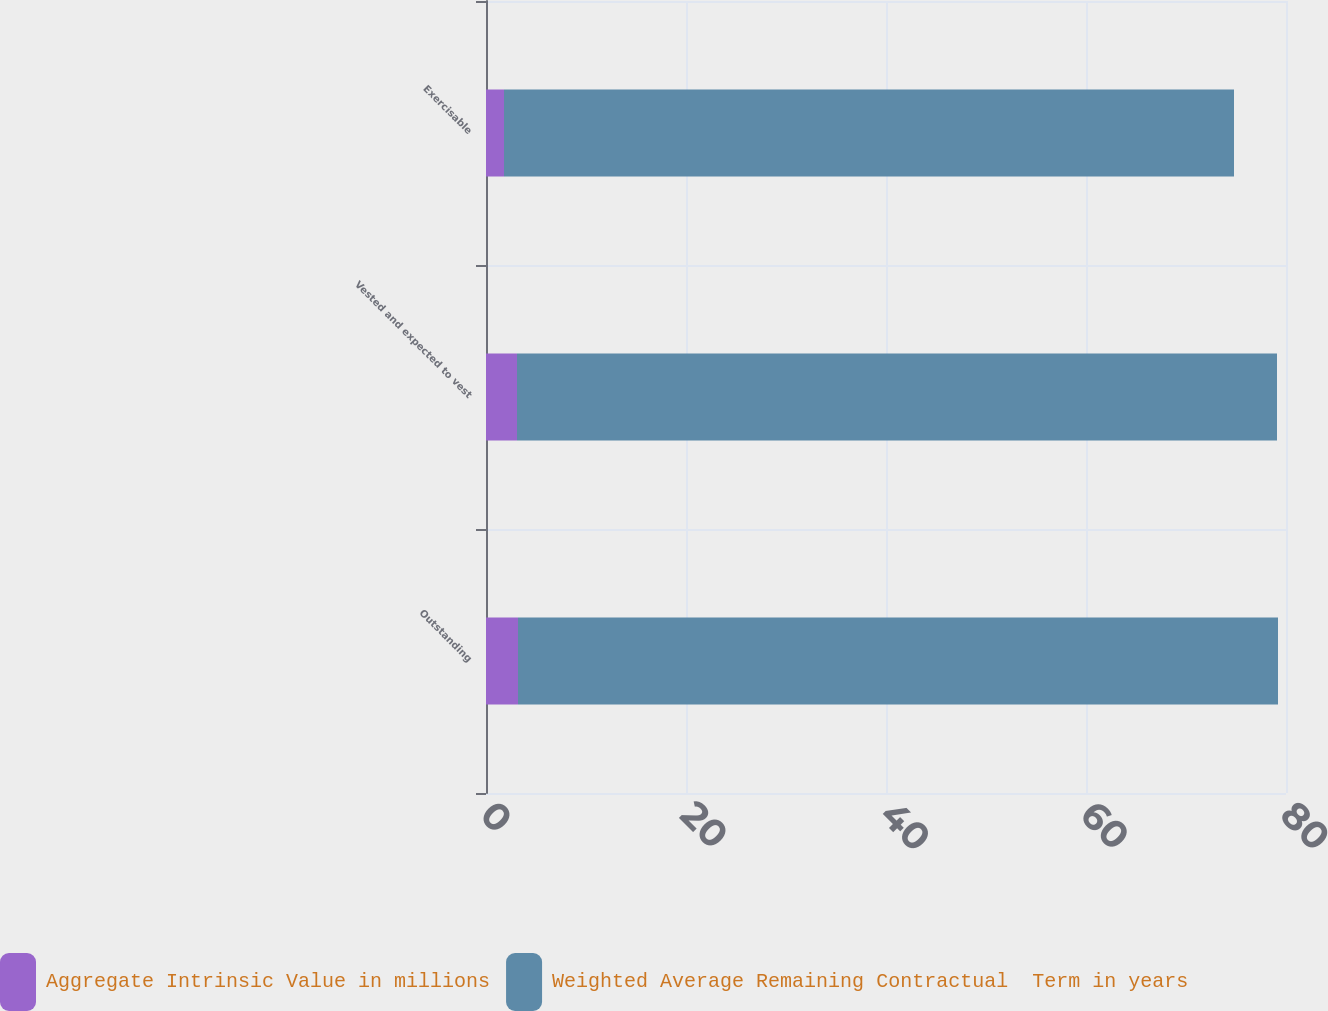Convert chart. <chart><loc_0><loc_0><loc_500><loc_500><stacked_bar_chart><ecel><fcel>Outstanding<fcel>Vested and expected to vest<fcel>Exercisable<nl><fcel>Aggregate Intrinsic Value in millions<fcel>3.2<fcel>3.1<fcel>1.8<nl><fcel>Weighted Average Remaining Contractual  Term in years<fcel>76<fcel>76<fcel>73<nl></chart> 